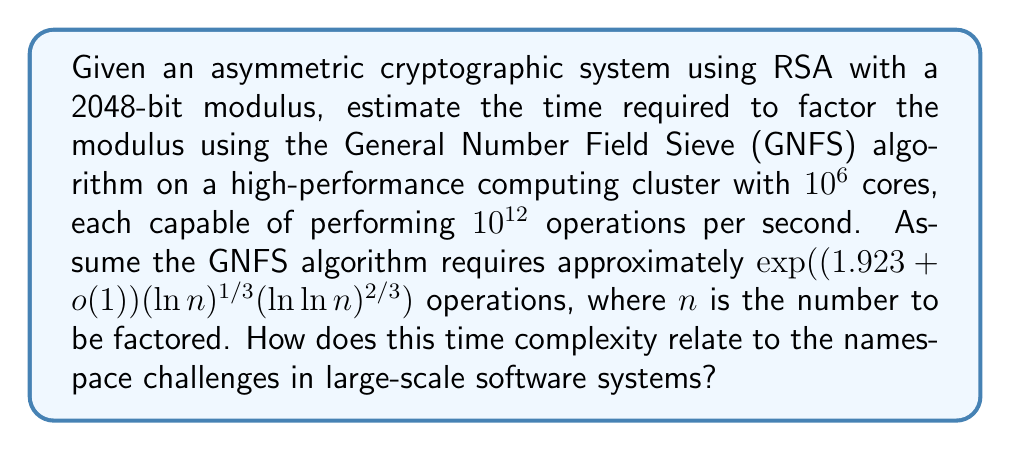Can you solve this math problem? 1. First, let's calculate the number of operations required for GNFS:
   $n = 2^{2048}$ (2048-bit modulus)
   Number of operations $\approx \exp((1.923 + o(1))(\ln 2^{2048})^{1/3}(\ln \ln 2^{2048})^{2/3})$

2. Simplify the expression:
   $\ln 2^{2048} = 2048 \ln 2$
   $\ln \ln 2^{2048} = \ln(2048 \ln 2)$

3. Neglecting the $o(1)$ term for estimation:
   Number of operations $\approx \exp(1.923 \cdot (2048 \ln 2)^{1/3} \cdot (\ln(2048 \ln 2))^{2/3})$

4. Calculate the result:
   Number of operations $\approx 1.18 \times 10^{29}$

5. Compute the total computing power:
   Total operations per second $= 10^6 \text{ cores} \times 10^{12} \text{ operations/second/core} = 10^{18} \text{ operations/second}$

6. Calculate the time required:
   Time $= \frac{1.18 \times 10^{29} \text{ operations}}{10^{18} \text{ operations/second}} \approx 1.18 \times 10^{11} \text{ seconds} \approx 3,741 \text{ years}$

7. Relation to namespace challenges:
   The exponential time complexity of factoring large numbers in asymmetric cryptography is analogous to the challenges of managing namespaces in large-scale software systems. As the system grows, the time and resources required to manage unique identifiers and prevent conflicts increase exponentially, similar to the factoring problem. This highlights the importance of efficient namespace management strategies and the potential need for hierarchical or distributed approaches in large-scale systems to mitigate scalability issues.
Answer: $\approx 3,741$ years; exponential complexity analogous to namespace management challenges in large-scale systems 